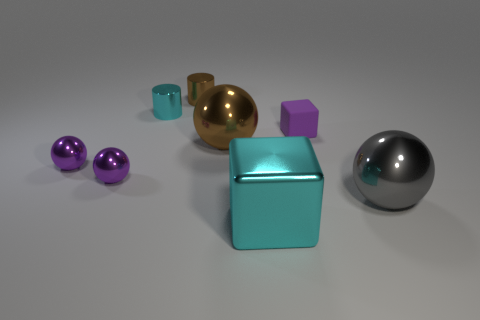What number of cyan metallic blocks are the same size as the gray object?
Your answer should be compact. 1. There is another object that is the same shape as the small purple rubber thing; what is its material?
Provide a succinct answer. Metal. The object that is behind the tiny cyan thing is what color?
Ensure brevity in your answer.  Brown. Are there more big brown spheres that are in front of the brown cylinder than red balls?
Your answer should be compact. Yes. The big metallic cube has what color?
Ensure brevity in your answer.  Cyan. What shape is the large metal object behind the big gray shiny thing on the right side of the brown metallic object that is in front of the small cyan metallic cylinder?
Ensure brevity in your answer.  Sphere. The thing that is both behind the big brown thing and to the right of the big cyan cube is made of what material?
Provide a short and direct response. Rubber. What shape is the thing that is on the right side of the purple object right of the large cyan metallic cube?
Offer a terse response. Sphere. Is there any other thing that is the same color as the small cube?
Offer a very short reply. Yes. There is a purple rubber cube; is its size the same as the brown object that is behind the tiny matte object?
Your answer should be very brief. Yes. 